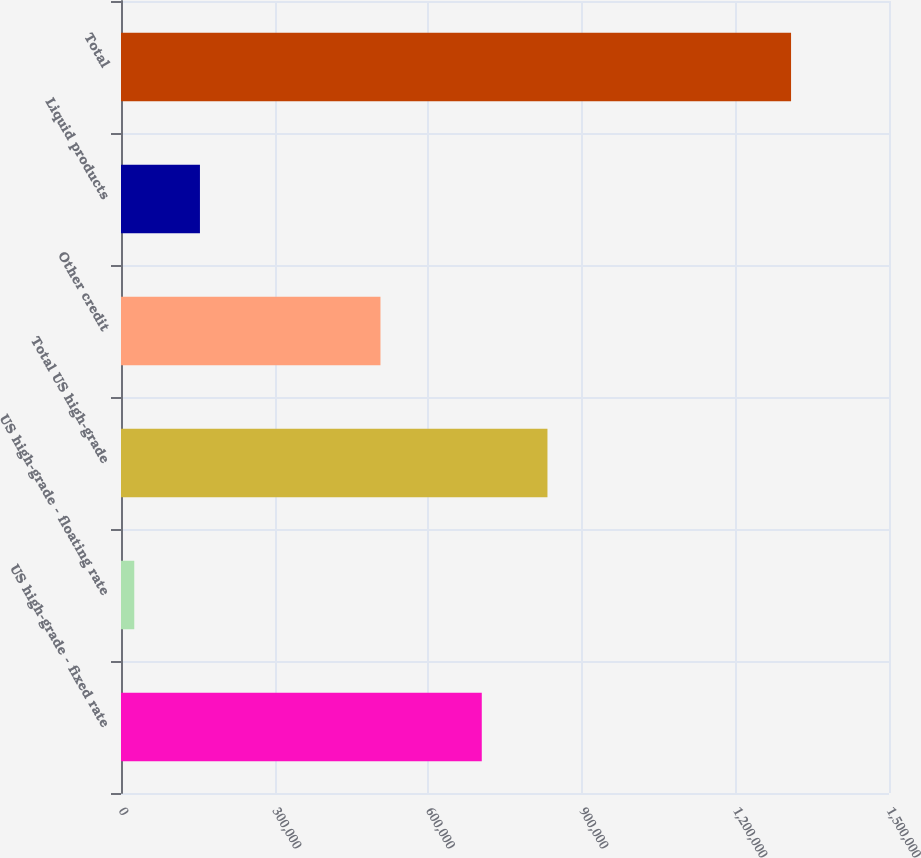Convert chart to OTSL. <chart><loc_0><loc_0><loc_500><loc_500><bar_chart><fcel>US high-grade - fixed rate<fcel>US high-grade - floating rate<fcel>Total US high-grade<fcel>Other credit<fcel>Liquid products<fcel>Total<nl><fcel>704648<fcel>25917<fcel>832926<fcel>506762<fcel>154196<fcel>1.3087e+06<nl></chart> 